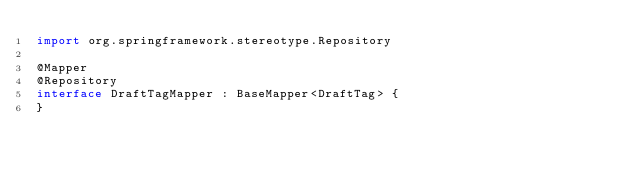Convert code to text. <code><loc_0><loc_0><loc_500><loc_500><_Kotlin_>import org.springframework.stereotype.Repository

@Mapper
@Repository
interface DraftTagMapper : BaseMapper<DraftTag> {
}</code> 